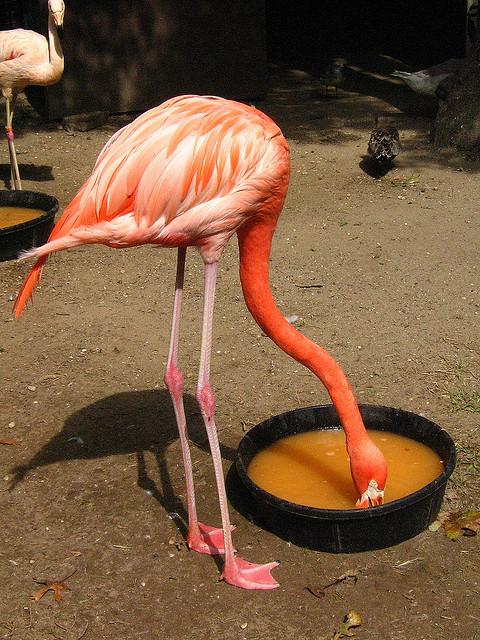What kind of food is in the pan?
Give a very brief answer. Soup. Is the liquid changing the birds color?
Be succinct. No. How many flamingos are here?
Be succinct. 2. Is this a real flamingo?
Quick response, please. Yes. 